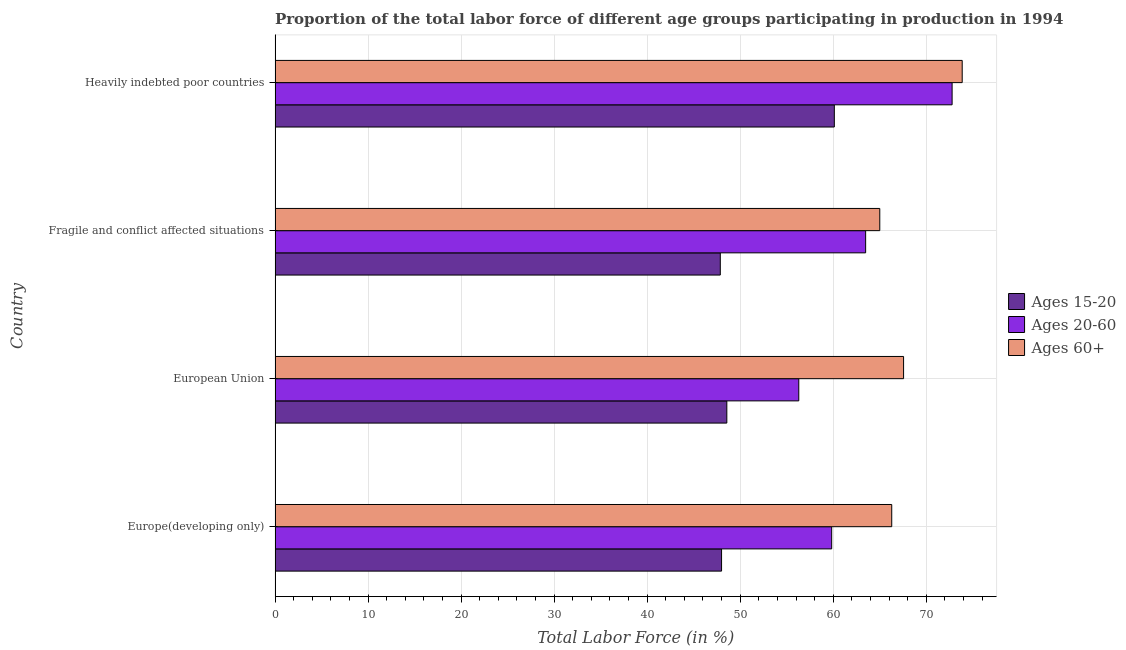Are the number of bars on each tick of the Y-axis equal?
Offer a very short reply. Yes. How many bars are there on the 2nd tick from the bottom?
Your answer should be very brief. 3. What is the label of the 1st group of bars from the top?
Your response must be concise. Heavily indebted poor countries. What is the percentage of labor force within the age group 15-20 in Heavily indebted poor countries?
Your answer should be compact. 60.12. Across all countries, what is the maximum percentage of labor force within the age group 20-60?
Provide a succinct answer. 72.78. Across all countries, what is the minimum percentage of labor force within the age group 20-60?
Provide a short and direct response. 56.3. In which country was the percentage of labor force above age 60 maximum?
Offer a terse response. Heavily indebted poor countries. What is the total percentage of labor force above age 60 in the graph?
Give a very brief answer. 272.73. What is the difference between the percentage of labor force above age 60 in Europe(developing only) and that in Heavily indebted poor countries?
Your response must be concise. -7.58. What is the difference between the percentage of labor force within the age group 20-60 in Fragile and conflict affected situations and the percentage of labor force within the age group 15-20 in European Union?
Give a very brief answer. 14.92. What is the average percentage of labor force above age 60 per country?
Keep it short and to the point. 68.18. What is the difference between the percentage of labor force within the age group 15-20 and percentage of labor force above age 60 in Fragile and conflict affected situations?
Your response must be concise. -17.14. In how many countries, is the percentage of labor force within the age group 15-20 greater than 42 %?
Make the answer very short. 4. What is the ratio of the percentage of labor force above age 60 in Europe(developing only) to that in European Union?
Keep it short and to the point. 0.98. What is the difference between the highest and the second highest percentage of labor force within the age group 15-20?
Keep it short and to the point. 11.56. What is the difference between the highest and the lowest percentage of labor force within the age group 20-60?
Ensure brevity in your answer.  16.48. What does the 1st bar from the top in Europe(developing only) represents?
Ensure brevity in your answer.  Ages 60+. What does the 3rd bar from the bottom in Europe(developing only) represents?
Keep it short and to the point. Ages 60+. Is it the case that in every country, the sum of the percentage of labor force within the age group 15-20 and percentage of labor force within the age group 20-60 is greater than the percentage of labor force above age 60?
Keep it short and to the point. Yes. Are all the bars in the graph horizontal?
Offer a terse response. Yes. How many countries are there in the graph?
Your response must be concise. 4. What is the difference between two consecutive major ticks on the X-axis?
Give a very brief answer. 10. Are the values on the major ticks of X-axis written in scientific E-notation?
Your response must be concise. No. Does the graph contain any zero values?
Your response must be concise. No. Does the graph contain grids?
Provide a short and direct response. Yes. Where does the legend appear in the graph?
Your answer should be very brief. Center right. How are the legend labels stacked?
Provide a succinct answer. Vertical. What is the title of the graph?
Make the answer very short. Proportion of the total labor force of different age groups participating in production in 1994. Does "Social Protection and Labor" appear as one of the legend labels in the graph?
Offer a very short reply. No. What is the label or title of the X-axis?
Keep it short and to the point. Total Labor Force (in %). What is the Total Labor Force (in %) of Ages 15-20 in Europe(developing only)?
Keep it short and to the point. 48. What is the Total Labor Force (in %) in Ages 20-60 in Europe(developing only)?
Make the answer very short. 59.84. What is the Total Labor Force (in %) of Ages 60+ in Europe(developing only)?
Provide a succinct answer. 66.29. What is the Total Labor Force (in %) of Ages 15-20 in European Union?
Keep it short and to the point. 48.57. What is the Total Labor Force (in %) in Ages 20-60 in European Union?
Make the answer very short. 56.3. What is the Total Labor Force (in %) in Ages 60+ in European Union?
Provide a succinct answer. 67.57. What is the Total Labor Force (in %) of Ages 15-20 in Fragile and conflict affected situations?
Your response must be concise. 47.86. What is the Total Labor Force (in %) of Ages 20-60 in Fragile and conflict affected situations?
Make the answer very short. 63.49. What is the Total Labor Force (in %) of Ages 60+ in Fragile and conflict affected situations?
Your response must be concise. 65.01. What is the Total Labor Force (in %) in Ages 15-20 in Heavily indebted poor countries?
Provide a short and direct response. 60.12. What is the Total Labor Force (in %) in Ages 20-60 in Heavily indebted poor countries?
Your answer should be very brief. 72.78. What is the Total Labor Force (in %) of Ages 60+ in Heavily indebted poor countries?
Ensure brevity in your answer.  73.87. Across all countries, what is the maximum Total Labor Force (in %) in Ages 15-20?
Your response must be concise. 60.12. Across all countries, what is the maximum Total Labor Force (in %) in Ages 20-60?
Your response must be concise. 72.78. Across all countries, what is the maximum Total Labor Force (in %) of Ages 60+?
Provide a succinct answer. 73.87. Across all countries, what is the minimum Total Labor Force (in %) in Ages 15-20?
Provide a succinct answer. 47.86. Across all countries, what is the minimum Total Labor Force (in %) in Ages 20-60?
Make the answer very short. 56.3. Across all countries, what is the minimum Total Labor Force (in %) in Ages 60+?
Your answer should be very brief. 65.01. What is the total Total Labor Force (in %) of Ages 15-20 in the graph?
Provide a succinct answer. 204.55. What is the total Total Labor Force (in %) in Ages 20-60 in the graph?
Provide a succinct answer. 252.41. What is the total Total Labor Force (in %) in Ages 60+ in the graph?
Make the answer very short. 272.73. What is the difference between the Total Labor Force (in %) of Ages 15-20 in Europe(developing only) and that in European Union?
Offer a very short reply. -0.57. What is the difference between the Total Labor Force (in %) of Ages 20-60 in Europe(developing only) and that in European Union?
Ensure brevity in your answer.  3.54. What is the difference between the Total Labor Force (in %) of Ages 60+ in Europe(developing only) and that in European Union?
Offer a very short reply. -1.27. What is the difference between the Total Labor Force (in %) of Ages 15-20 in Europe(developing only) and that in Fragile and conflict affected situations?
Give a very brief answer. 0.14. What is the difference between the Total Labor Force (in %) in Ages 20-60 in Europe(developing only) and that in Fragile and conflict affected situations?
Your answer should be very brief. -3.65. What is the difference between the Total Labor Force (in %) in Ages 60+ in Europe(developing only) and that in Fragile and conflict affected situations?
Keep it short and to the point. 1.28. What is the difference between the Total Labor Force (in %) in Ages 15-20 in Europe(developing only) and that in Heavily indebted poor countries?
Provide a succinct answer. -12.12. What is the difference between the Total Labor Force (in %) of Ages 20-60 in Europe(developing only) and that in Heavily indebted poor countries?
Your answer should be very brief. -12.95. What is the difference between the Total Labor Force (in %) in Ages 60+ in Europe(developing only) and that in Heavily indebted poor countries?
Provide a short and direct response. -7.58. What is the difference between the Total Labor Force (in %) of Ages 15-20 in European Union and that in Fragile and conflict affected situations?
Offer a very short reply. 0.7. What is the difference between the Total Labor Force (in %) in Ages 20-60 in European Union and that in Fragile and conflict affected situations?
Offer a terse response. -7.19. What is the difference between the Total Labor Force (in %) of Ages 60+ in European Union and that in Fragile and conflict affected situations?
Make the answer very short. 2.56. What is the difference between the Total Labor Force (in %) in Ages 15-20 in European Union and that in Heavily indebted poor countries?
Keep it short and to the point. -11.56. What is the difference between the Total Labor Force (in %) in Ages 20-60 in European Union and that in Heavily indebted poor countries?
Provide a short and direct response. -16.48. What is the difference between the Total Labor Force (in %) in Ages 60+ in European Union and that in Heavily indebted poor countries?
Offer a terse response. -6.3. What is the difference between the Total Labor Force (in %) of Ages 15-20 in Fragile and conflict affected situations and that in Heavily indebted poor countries?
Offer a very short reply. -12.26. What is the difference between the Total Labor Force (in %) in Ages 20-60 in Fragile and conflict affected situations and that in Heavily indebted poor countries?
Provide a short and direct response. -9.3. What is the difference between the Total Labor Force (in %) of Ages 60+ in Fragile and conflict affected situations and that in Heavily indebted poor countries?
Offer a very short reply. -8.86. What is the difference between the Total Labor Force (in %) in Ages 15-20 in Europe(developing only) and the Total Labor Force (in %) in Ages 20-60 in European Union?
Provide a short and direct response. -8.3. What is the difference between the Total Labor Force (in %) of Ages 15-20 in Europe(developing only) and the Total Labor Force (in %) of Ages 60+ in European Union?
Offer a very short reply. -19.57. What is the difference between the Total Labor Force (in %) of Ages 20-60 in Europe(developing only) and the Total Labor Force (in %) of Ages 60+ in European Union?
Your response must be concise. -7.73. What is the difference between the Total Labor Force (in %) of Ages 15-20 in Europe(developing only) and the Total Labor Force (in %) of Ages 20-60 in Fragile and conflict affected situations?
Provide a succinct answer. -15.49. What is the difference between the Total Labor Force (in %) of Ages 15-20 in Europe(developing only) and the Total Labor Force (in %) of Ages 60+ in Fragile and conflict affected situations?
Your response must be concise. -17.01. What is the difference between the Total Labor Force (in %) in Ages 20-60 in Europe(developing only) and the Total Labor Force (in %) in Ages 60+ in Fragile and conflict affected situations?
Provide a succinct answer. -5.17. What is the difference between the Total Labor Force (in %) in Ages 15-20 in Europe(developing only) and the Total Labor Force (in %) in Ages 20-60 in Heavily indebted poor countries?
Provide a succinct answer. -24.78. What is the difference between the Total Labor Force (in %) in Ages 15-20 in Europe(developing only) and the Total Labor Force (in %) in Ages 60+ in Heavily indebted poor countries?
Your response must be concise. -25.87. What is the difference between the Total Labor Force (in %) in Ages 20-60 in Europe(developing only) and the Total Labor Force (in %) in Ages 60+ in Heavily indebted poor countries?
Offer a very short reply. -14.03. What is the difference between the Total Labor Force (in %) of Ages 15-20 in European Union and the Total Labor Force (in %) of Ages 20-60 in Fragile and conflict affected situations?
Your answer should be very brief. -14.92. What is the difference between the Total Labor Force (in %) in Ages 15-20 in European Union and the Total Labor Force (in %) in Ages 60+ in Fragile and conflict affected situations?
Offer a terse response. -16.44. What is the difference between the Total Labor Force (in %) of Ages 20-60 in European Union and the Total Labor Force (in %) of Ages 60+ in Fragile and conflict affected situations?
Your answer should be compact. -8.71. What is the difference between the Total Labor Force (in %) of Ages 15-20 in European Union and the Total Labor Force (in %) of Ages 20-60 in Heavily indebted poor countries?
Give a very brief answer. -24.22. What is the difference between the Total Labor Force (in %) in Ages 15-20 in European Union and the Total Labor Force (in %) in Ages 60+ in Heavily indebted poor countries?
Your answer should be very brief. -25.3. What is the difference between the Total Labor Force (in %) in Ages 20-60 in European Union and the Total Labor Force (in %) in Ages 60+ in Heavily indebted poor countries?
Your response must be concise. -17.57. What is the difference between the Total Labor Force (in %) in Ages 15-20 in Fragile and conflict affected situations and the Total Labor Force (in %) in Ages 20-60 in Heavily indebted poor countries?
Your answer should be very brief. -24.92. What is the difference between the Total Labor Force (in %) of Ages 15-20 in Fragile and conflict affected situations and the Total Labor Force (in %) of Ages 60+ in Heavily indebted poor countries?
Give a very brief answer. -26.01. What is the difference between the Total Labor Force (in %) of Ages 20-60 in Fragile and conflict affected situations and the Total Labor Force (in %) of Ages 60+ in Heavily indebted poor countries?
Your answer should be compact. -10.38. What is the average Total Labor Force (in %) in Ages 15-20 per country?
Provide a succinct answer. 51.14. What is the average Total Labor Force (in %) in Ages 20-60 per country?
Your response must be concise. 63.1. What is the average Total Labor Force (in %) in Ages 60+ per country?
Keep it short and to the point. 68.18. What is the difference between the Total Labor Force (in %) of Ages 15-20 and Total Labor Force (in %) of Ages 20-60 in Europe(developing only)?
Make the answer very short. -11.84. What is the difference between the Total Labor Force (in %) in Ages 15-20 and Total Labor Force (in %) in Ages 60+ in Europe(developing only)?
Offer a terse response. -18.29. What is the difference between the Total Labor Force (in %) of Ages 20-60 and Total Labor Force (in %) of Ages 60+ in Europe(developing only)?
Ensure brevity in your answer.  -6.45. What is the difference between the Total Labor Force (in %) in Ages 15-20 and Total Labor Force (in %) in Ages 20-60 in European Union?
Your answer should be very brief. -7.73. What is the difference between the Total Labor Force (in %) of Ages 15-20 and Total Labor Force (in %) of Ages 60+ in European Union?
Your answer should be compact. -19. What is the difference between the Total Labor Force (in %) in Ages 20-60 and Total Labor Force (in %) in Ages 60+ in European Union?
Ensure brevity in your answer.  -11.27. What is the difference between the Total Labor Force (in %) in Ages 15-20 and Total Labor Force (in %) in Ages 20-60 in Fragile and conflict affected situations?
Keep it short and to the point. -15.63. What is the difference between the Total Labor Force (in %) in Ages 15-20 and Total Labor Force (in %) in Ages 60+ in Fragile and conflict affected situations?
Offer a very short reply. -17.14. What is the difference between the Total Labor Force (in %) of Ages 20-60 and Total Labor Force (in %) of Ages 60+ in Fragile and conflict affected situations?
Your answer should be compact. -1.52. What is the difference between the Total Labor Force (in %) of Ages 15-20 and Total Labor Force (in %) of Ages 20-60 in Heavily indebted poor countries?
Make the answer very short. -12.66. What is the difference between the Total Labor Force (in %) of Ages 15-20 and Total Labor Force (in %) of Ages 60+ in Heavily indebted poor countries?
Ensure brevity in your answer.  -13.75. What is the difference between the Total Labor Force (in %) in Ages 20-60 and Total Labor Force (in %) in Ages 60+ in Heavily indebted poor countries?
Provide a short and direct response. -1.08. What is the ratio of the Total Labor Force (in %) in Ages 15-20 in Europe(developing only) to that in European Union?
Your answer should be very brief. 0.99. What is the ratio of the Total Labor Force (in %) in Ages 20-60 in Europe(developing only) to that in European Union?
Provide a short and direct response. 1.06. What is the ratio of the Total Labor Force (in %) of Ages 60+ in Europe(developing only) to that in European Union?
Provide a short and direct response. 0.98. What is the ratio of the Total Labor Force (in %) of Ages 15-20 in Europe(developing only) to that in Fragile and conflict affected situations?
Make the answer very short. 1. What is the ratio of the Total Labor Force (in %) in Ages 20-60 in Europe(developing only) to that in Fragile and conflict affected situations?
Your answer should be very brief. 0.94. What is the ratio of the Total Labor Force (in %) in Ages 60+ in Europe(developing only) to that in Fragile and conflict affected situations?
Provide a succinct answer. 1.02. What is the ratio of the Total Labor Force (in %) of Ages 15-20 in Europe(developing only) to that in Heavily indebted poor countries?
Your response must be concise. 0.8. What is the ratio of the Total Labor Force (in %) in Ages 20-60 in Europe(developing only) to that in Heavily indebted poor countries?
Your answer should be very brief. 0.82. What is the ratio of the Total Labor Force (in %) in Ages 60+ in Europe(developing only) to that in Heavily indebted poor countries?
Your response must be concise. 0.9. What is the ratio of the Total Labor Force (in %) in Ages 15-20 in European Union to that in Fragile and conflict affected situations?
Provide a short and direct response. 1.01. What is the ratio of the Total Labor Force (in %) in Ages 20-60 in European Union to that in Fragile and conflict affected situations?
Ensure brevity in your answer.  0.89. What is the ratio of the Total Labor Force (in %) in Ages 60+ in European Union to that in Fragile and conflict affected situations?
Offer a very short reply. 1.04. What is the ratio of the Total Labor Force (in %) of Ages 15-20 in European Union to that in Heavily indebted poor countries?
Offer a terse response. 0.81. What is the ratio of the Total Labor Force (in %) in Ages 20-60 in European Union to that in Heavily indebted poor countries?
Offer a terse response. 0.77. What is the ratio of the Total Labor Force (in %) in Ages 60+ in European Union to that in Heavily indebted poor countries?
Offer a terse response. 0.91. What is the ratio of the Total Labor Force (in %) of Ages 15-20 in Fragile and conflict affected situations to that in Heavily indebted poor countries?
Make the answer very short. 0.8. What is the ratio of the Total Labor Force (in %) of Ages 20-60 in Fragile and conflict affected situations to that in Heavily indebted poor countries?
Your answer should be very brief. 0.87. What is the ratio of the Total Labor Force (in %) of Ages 60+ in Fragile and conflict affected situations to that in Heavily indebted poor countries?
Make the answer very short. 0.88. What is the difference between the highest and the second highest Total Labor Force (in %) in Ages 15-20?
Offer a terse response. 11.56. What is the difference between the highest and the second highest Total Labor Force (in %) of Ages 20-60?
Your answer should be very brief. 9.3. What is the difference between the highest and the second highest Total Labor Force (in %) of Ages 60+?
Keep it short and to the point. 6.3. What is the difference between the highest and the lowest Total Labor Force (in %) in Ages 15-20?
Provide a succinct answer. 12.26. What is the difference between the highest and the lowest Total Labor Force (in %) in Ages 20-60?
Keep it short and to the point. 16.48. What is the difference between the highest and the lowest Total Labor Force (in %) in Ages 60+?
Your response must be concise. 8.86. 